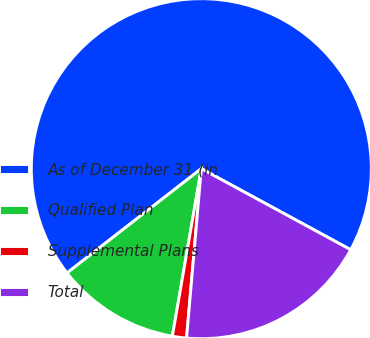<chart> <loc_0><loc_0><loc_500><loc_500><pie_chart><fcel>As of December 31 (in<fcel>Qualified Plan<fcel>Supplemental Plans<fcel>Total<nl><fcel>68.42%<fcel>11.77%<fcel>1.34%<fcel>18.47%<nl></chart> 